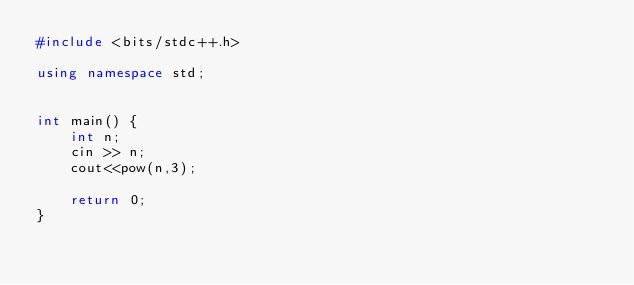<code> <loc_0><loc_0><loc_500><loc_500><_C++_>#include <bits/stdc++.h>

using namespace std;
 
 
int main() {
    int n;
    cin >> n;
    cout<<pow(n,3);

    return 0;
}</code> 